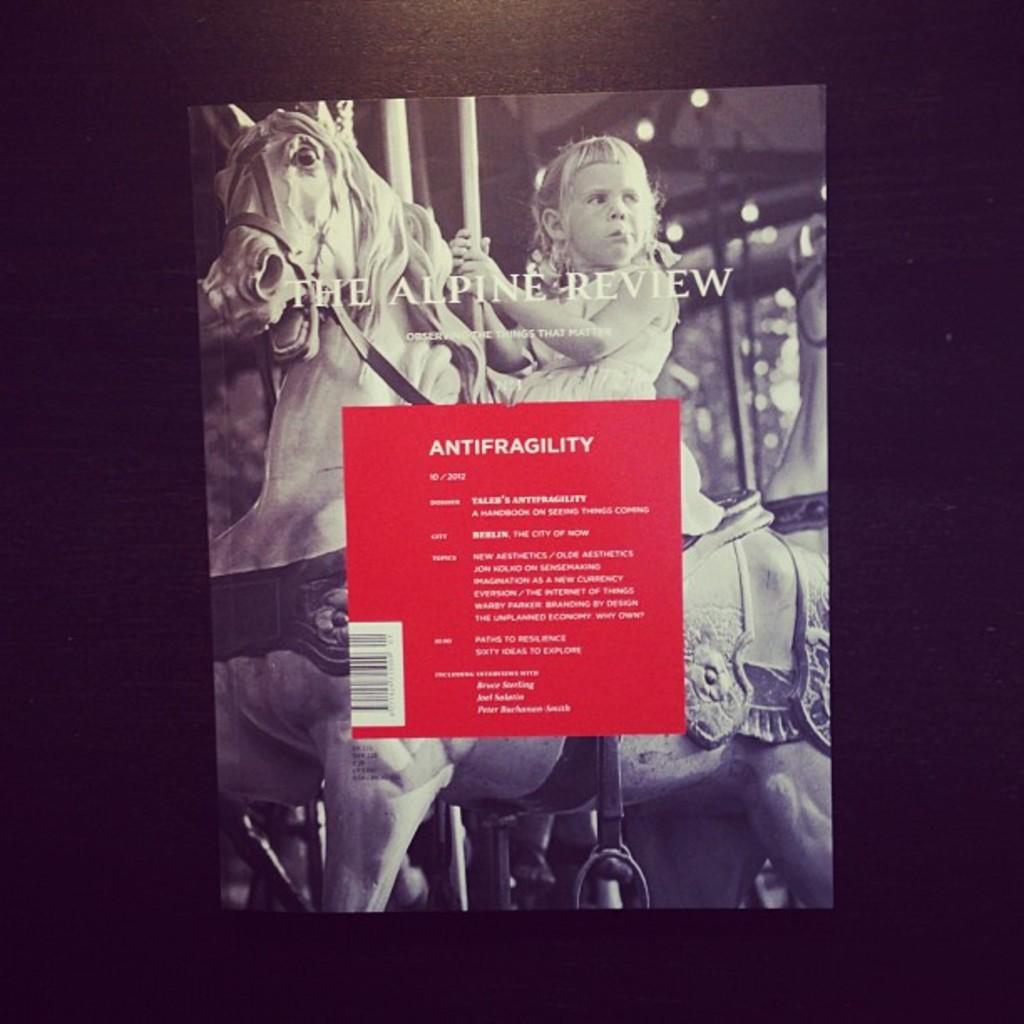What is present in the image that features a design or message? There is a poster in the image. Where is the poster located? The poster is on a surface. What is depicted on the poster? The poster features a girl sitting on a horse. Are there any additional elements in the poster? Yes, there is a pole, lights, and text on the poster. What time is it in the image? The time is not mentioned or depicted in the image. Are there any sticks visible in the image? There are no sticks present in the image; the poster features a girl sitting on a horse, a pole, lights, and text. 